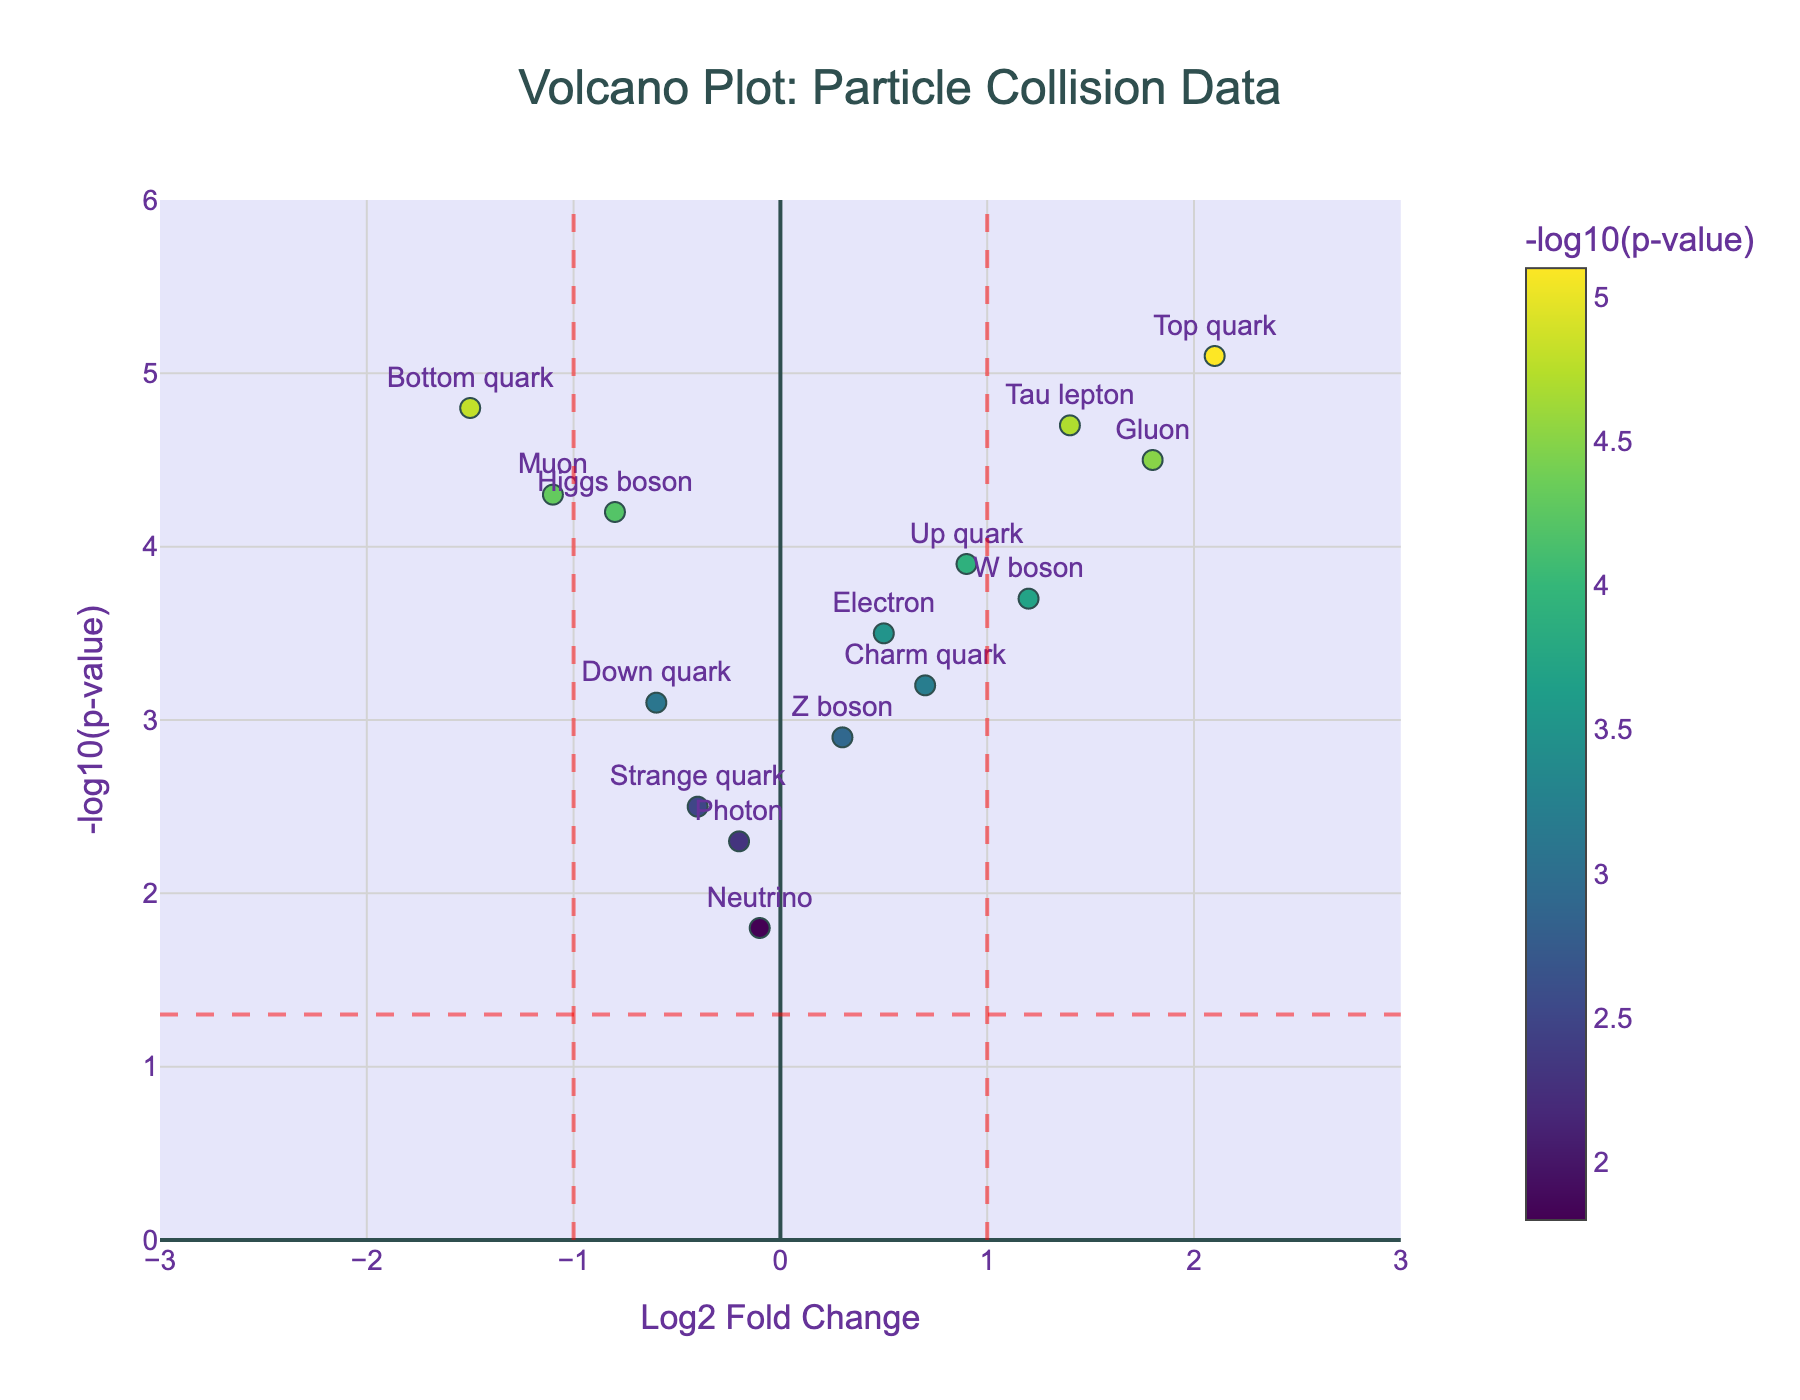What's the title of the plot? The title of the plot is found at the top center. It indicates what the plot is showing.
Answer: Volcano Plot: Particle Collision Data Which axis represents the "Log2 Fold Change"? The x-axis is labeled "Log2 Fold Change," so it represents the log2 fold change values of the particles.
Answer: x-axis How many particles have a negative log2 fold change? There are six particles with log2 fold change values that are negative: "Higgs boson," "Bottom quark," "Strange quark," "Down quark," "Photon," and "Muon."
Answer: Six Is the "Top quark" statistically significant based on the p-value threshold used in the plot? The p-value threshold is marked by a horizontal line at y = 1.301 (i.e., -log10(0.05)). The "Top quark" is above this line indicating it is statistically significant.
Answer: Yes Which particle has the highest log2 fold change value? The "Top quark" is at the highest log2 fold change value on the x-axis, which is 2.1.
Answer: Top quark Compare the statistical significance of the "W boson" and "Gluon." Which one is more statistically significant? We compare the negative log10 p-values, as higher values indicate more statistical significance. The "Gluon" has a higher negative log10 p-value (4.5) compared to "W boson" (3.7).
Answer: Gluon What does the color scale represent in the plot? The color scale indicates the negative log10 p-value of each particle, with darker colors representing higher values.
Answer: Negative log10 p-value Which particle has the smallest negative log10 p-value and what is its value? The "Neutrino" has the smallest negative log10 p-value visible at the lowest point on the y-axis, which is 1.8.
Answer: Neutrino, 1.8 How many particles have a statistically significant p-value and a log2 fold change greater than or equal to 1? We count the particles above the horizontal threshold (y = 1.301) and to the right of the vertical threshold (x ≥ 1): "Top quark," "W boson," "Gluon," and "Tau lepton."
Answer: Four 